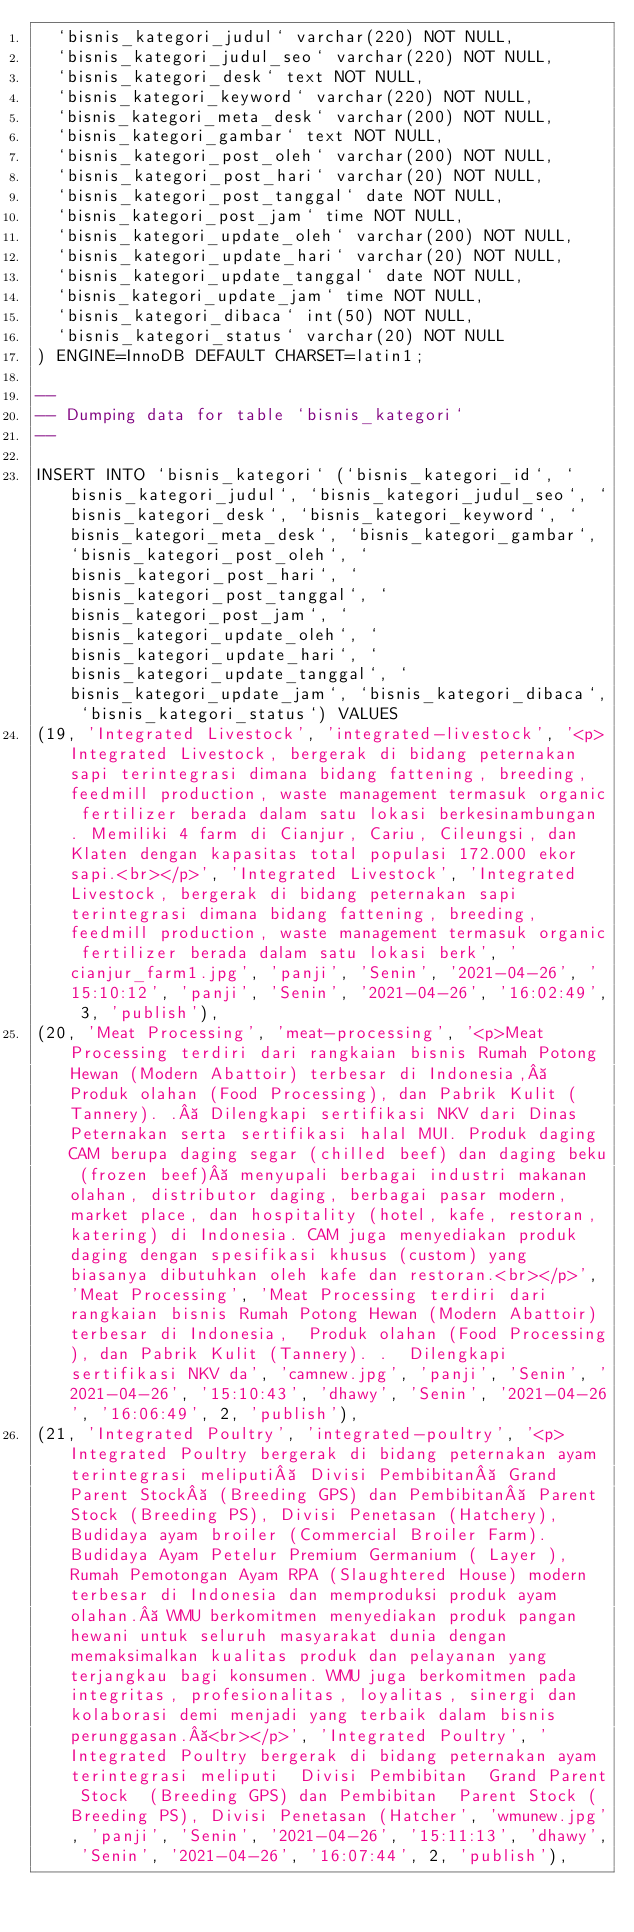Convert code to text. <code><loc_0><loc_0><loc_500><loc_500><_SQL_>  `bisnis_kategori_judul` varchar(220) NOT NULL,
  `bisnis_kategori_judul_seo` varchar(220) NOT NULL,
  `bisnis_kategori_desk` text NOT NULL,
  `bisnis_kategori_keyword` varchar(220) NOT NULL,
  `bisnis_kategori_meta_desk` varchar(200) NOT NULL,
  `bisnis_kategori_gambar` text NOT NULL,
  `bisnis_kategori_post_oleh` varchar(200) NOT NULL,
  `bisnis_kategori_post_hari` varchar(20) NOT NULL,
  `bisnis_kategori_post_tanggal` date NOT NULL,
  `bisnis_kategori_post_jam` time NOT NULL,
  `bisnis_kategori_update_oleh` varchar(200) NOT NULL,
  `bisnis_kategori_update_hari` varchar(20) NOT NULL,
  `bisnis_kategori_update_tanggal` date NOT NULL,
  `bisnis_kategori_update_jam` time NOT NULL,
  `bisnis_kategori_dibaca` int(50) NOT NULL,
  `bisnis_kategori_status` varchar(20) NOT NULL
) ENGINE=InnoDB DEFAULT CHARSET=latin1;

--
-- Dumping data for table `bisnis_kategori`
--

INSERT INTO `bisnis_kategori` (`bisnis_kategori_id`, `bisnis_kategori_judul`, `bisnis_kategori_judul_seo`, `bisnis_kategori_desk`, `bisnis_kategori_keyword`, `bisnis_kategori_meta_desk`, `bisnis_kategori_gambar`, `bisnis_kategori_post_oleh`, `bisnis_kategori_post_hari`, `bisnis_kategori_post_tanggal`, `bisnis_kategori_post_jam`, `bisnis_kategori_update_oleh`, `bisnis_kategori_update_hari`, `bisnis_kategori_update_tanggal`, `bisnis_kategori_update_jam`, `bisnis_kategori_dibaca`, `bisnis_kategori_status`) VALUES
(19, 'Integrated Livestock', 'integrated-livestock', '<p>Integrated Livestock, bergerak di bidang peternakan sapi terintegrasi dimana bidang fattening, breeding, feedmill production, waste management termasuk organic fertilizer berada dalam satu lokasi berkesinambungan . Memiliki 4 farm di Cianjur, Cariu, Cileungsi, dan Klaten dengan kapasitas total populasi 172.000 ekor sapi.<br></p>', 'Integrated Livestock', 'Integrated Livestock, bergerak di bidang peternakan sapi terintegrasi dimana bidang fattening, breeding, feedmill production, waste management termasuk organic fertilizer berada dalam satu lokasi berk', 'cianjur_farm1.jpg', 'panji', 'Senin', '2021-04-26', '15:10:12', 'panji', 'Senin', '2021-04-26', '16:02:49', 3, 'publish'),
(20, 'Meat Processing', 'meat-processing', '<p>Meat Processing terdiri dari rangkaian bisnis Rumah Potong Hewan (Modern Abattoir) terbesar di Indonesia,  Produk olahan (Food Processing), dan Pabrik Kulit (Tannery). .  Dilengkapi sertifikasi NKV dari Dinas Peternakan serta sertifikasi halal MUI. Produk daging CAM berupa daging segar (chilled beef) dan daging beku (frozen beef)  menyupali berbagai industri makanan olahan, distributor daging, berbagai pasar modern, market place, dan hospitality (hotel, kafe, restoran, katering) di Indonesia. CAM juga menyediakan produk daging dengan spesifikasi khusus (custom) yang biasanya dibutuhkan oleh kafe dan restoran.<br></p>', 'Meat Processing', 'Meat Processing terdiri dari rangkaian bisnis Rumah Potong Hewan (Modern Abattoir) terbesar di Indonesia,  Produk olahan (Food Processing), dan Pabrik Kulit (Tannery). .  Dilengkapi sertifikasi NKV da', 'camnew.jpg', 'panji', 'Senin', '2021-04-26', '15:10:43', 'dhawy', 'Senin', '2021-04-26', '16:06:49', 2, 'publish'),
(21, 'Integrated Poultry', 'integrated-poultry', '<p>Integrated Poultry bergerak di bidang peternakan ayam terintegrasi meliputi  Divisi Pembibitan  Grand Parent Stock  (Breeding GPS) dan Pembibitan  Parent Stock (Breeding PS), Divisi Penetasan (Hatchery), Budidaya ayam broiler (Commercial Broiler Farm). Budidaya Ayam Petelur Premium Germanium ( Layer ), Rumah Pemotongan Ayam RPA (Slaughtered House) modern terbesar di Indonesia dan memproduksi produk ayam olahan.  WMU berkomitmen menyediakan produk pangan hewani untuk seluruh masyarakat dunia dengan memaksimalkan kualitas produk dan pelayanan yang terjangkau bagi konsumen. WMU juga berkomitmen pada integritas, profesionalitas, loyalitas, sinergi dan kolaborasi demi menjadi yang terbaik dalam bisnis perunggasan. <br></p>', 'Integrated Poultry', 'Integrated Poultry bergerak di bidang peternakan ayam terintegrasi meliputi  Divisi Pembibitan  Grand Parent Stock  (Breeding GPS) dan Pembibitan  Parent Stock (Breeding PS), Divisi Penetasan (Hatcher', 'wmunew.jpg', 'panji', 'Senin', '2021-04-26', '15:11:13', 'dhawy', 'Senin', '2021-04-26', '16:07:44', 2, 'publish'),</code> 